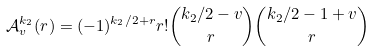Convert formula to latex. <formula><loc_0><loc_0><loc_500><loc_500>\mathcal { A } _ { v } ^ { k _ { 2 } } ( r ) = ( - 1 ) ^ { k _ { 2 } / 2 + r } r ! \binom { k _ { 2 } / 2 - v } { r } \binom { k _ { 2 } / 2 - 1 + v } { r }</formula> 